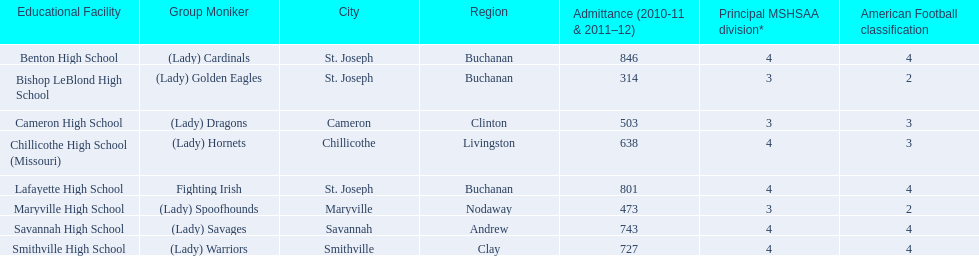How many are enrolled at each school? Benton High School, 846, Bishop LeBlond High School, 314, Cameron High School, 503, Chillicothe High School (Missouri), 638, Lafayette High School, 801, Maryville High School, 473, Savannah High School, 743, Smithville High School, 727. Which school has at only three football classes? Cameron High School, 3, Chillicothe High School (Missouri), 3. Which school has 638 enrolled and 3 football classes? Chillicothe High School (Missouri). 